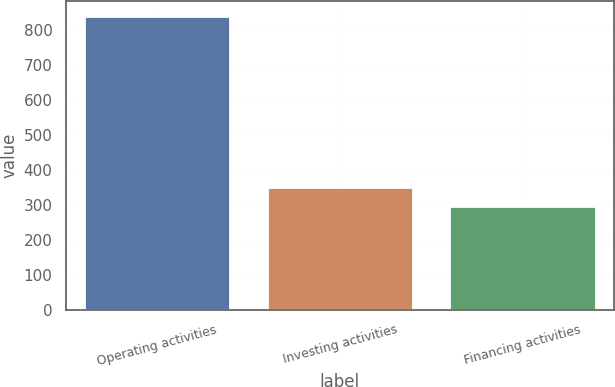Convert chart to OTSL. <chart><loc_0><loc_0><loc_500><loc_500><bar_chart><fcel>Operating activities<fcel>Investing activities<fcel>Financing activities<nl><fcel>840<fcel>352.2<fcel>298<nl></chart> 